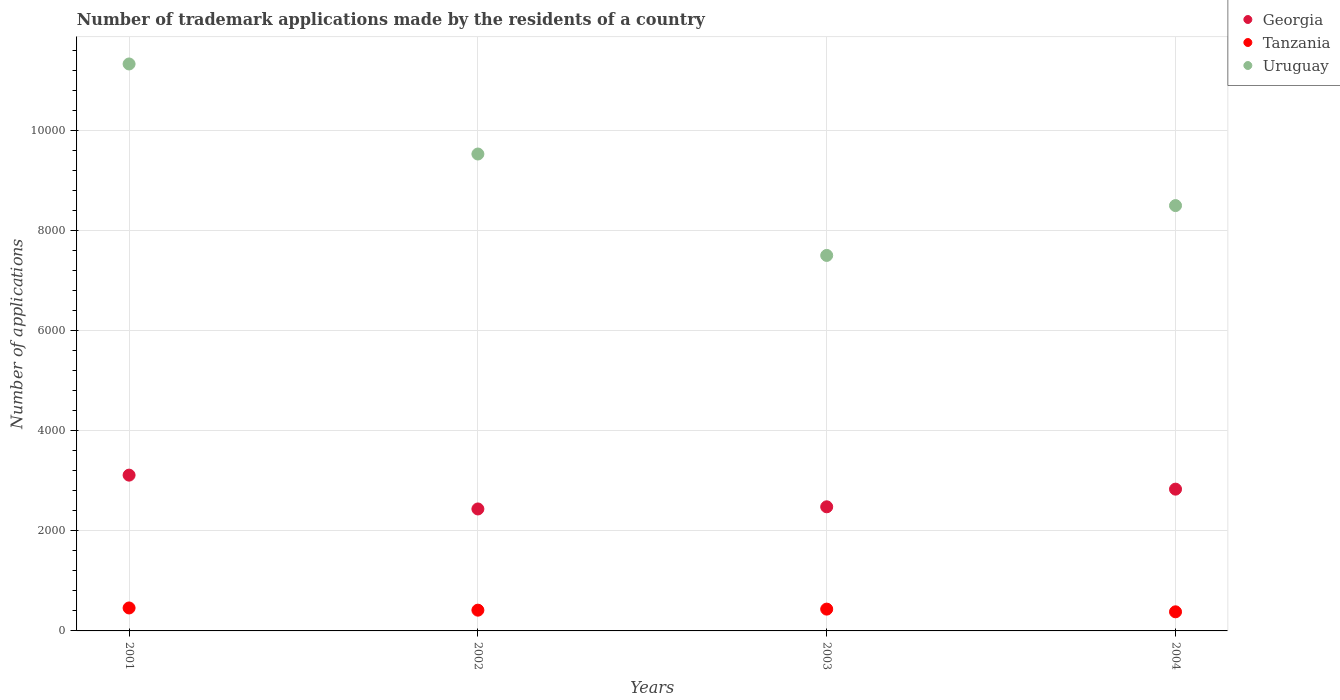How many different coloured dotlines are there?
Your response must be concise. 3. Is the number of dotlines equal to the number of legend labels?
Provide a succinct answer. Yes. What is the number of trademark applications made by the residents in Uruguay in 2001?
Provide a short and direct response. 1.13e+04. Across all years, what is the maximum number of trademark applications made by the residents in Uruguay?
Provide a succinct answer. 1.13e+04. Across all years, what is the minimum number of trademark applications made by the residents in Uruguay?
Offer a terse response. 7506. In which year was the number of trademark applications made by the residents in Georgia minimum?
Ensure brevity in your answer.  2002. What is the total number of trademark applications made by the residents in Uruguay in the graph?
Give a very brief answer. 3.69e+04. What is the difference between the number of trademark applications made by the residents in Tanzania in 2001 and that in 2002?
Give a very brief answer. 44. What is the difference between the number of trademark applications made by the residents in Tanzania in 2002 and the number of trademark applications made by the residents in Georgia in 2003?
Offer a terse response. -2066. What is the average number of trademark applications made by the residents in Uruguay per year?
Offer a terse response. 9218.5. In the year 2003, what is the difference between the number of trademark applications made by the residents in Tanzania and number of trademark applications made by the residents in Georgia?
Make the answer very short. -2045. What is the ratio of the number of trademark applications made by the residents in Tanzania in 2001 to that in 2004?
Offer a terse response. 1.2. Is the number of trademark applications made by the residents in Uruguay in 2002 less than that in 2003?
Make the answer very short. No. What is the difference between the highest and the second highest number of trademark applications made by the residents in Georgia?
Ensure brevity in your answer.  280. What is the difference between the highest and the lowest number of trademark applications made by the residents in Georgia?
Offer a very short reply. 676. Is the sum of the number of trademark applications made by the residents in Georgia in 2001 and 2002 greater than the maximum number of trademark applications made by the residents in Tanzania across all years?
Give a very brief answer. Yes. Does the number of trademark applications made by the residents in Georgia monotonically increase over the years?
Your answer should be compact. No. Is the number of trademark applications made by the residents in Uruguay strictly greater than the number of trademark applications made by the residents in Tanzania over the years?
Offer a terse response. Yes. How many years are there in the graph?
Keep it short and to the point. 4. What is the difference between two consecutive major ticks on the Y-axis?
Make the answer very short. 2000. Are the values on the major ticks of Y-axis written in scientific E-notation?
Offer a very short reply. No. Does the graph contain grids?
Offer a terse response. Yes. How many legend labels are there?
Your answer should be compact. 3. How are the legend labels stacked?
Provide a short and direct response. Vertical. What is the title of the graph?
Give a very brief answer. Number of trademark applications made by the residents of a country. What is the label or title of the X-axis?
Your answer should be very brief. Years. What is the label or title of the Y-axis?
Give a very brief answer. Number of applications. What is the Number of applications in Georgia in 2001?
Provide a short and direct response. 3114. What is the Number of applications of Tanzania in 2001?
Offer a terse response. 459. What is the Number of applications in Uruguay in 2001?
Give a very brief answer. 1.13e+04. What is the Number of applications of Georgia in 2002?
Keep it short and to the point. 2438. What is the Number of applications of Tanzania in 2002?
Offer a terse response. 415. What is the Number of applications in Uruguay in 2002?
Ensure brevity in your answer.  9533. What is the Number of applications in Georgia in 2003?
Keep it short and to the point. 2481. What is the Number of applications of Tanzania in 2003?
Offer a very short reply. 436. What is the Number of applications of Uruguay in 2003?
Your response must be concise. 7506. What is the Number of applications in Georgia in 2004?
Give a very brief answer. 2834. What is the Number of applications in Tanzania in 2004?
Give a very brief answer. 382. What is the Number of applications of Uruguay in 2004?
Provide a succinct answer. 8502. Across all years, what is the maximum Number of applications in Georgia?
Provide a succinct answer. 3114. Across all years, what is the maximum Number of applications of Tanzania?
Keep it short and to the point. 459. Across all years, what is the maximum Number of applications in Uruguay?
Keep it short and to the point. 1.13e+04. Across all years, what is the minimum Number of applications of Georgia?
Keep it short and to the point. 2438. Across all years, what is the minimum Number of applications in Tanzania?
Give a very brief answer. 382. Across all years, what is the minimum Number of applications of Uruguay?
Your answer should be very brief. 7506. What is the total Number of applications of Georgia in the graph?
Your answer should be compact. 1.09e+04. What is the total Number of applications of Tanzania in the graph?
Give a very brief answer. 1692. What is the total Number of applications in Uruguay in the graph?
Make the answer very short. 3.69e+04. What is the difference between the Number of applications in Georgia in 2001 and that in 2002?
Offer a very short reply. 676. What is the difference between the Number of applications in Tanzania in 2001 and that in 2002?
Ensure brevity in your answer.  44. What is the difference between the Number of applications of Uruguay in 2001 and that in 2002?
Give a very brief answer. 1800. What is the difference between the Number of applications in Georgia in 2001 and that in 2003?
Provide a short and direct response. 633. What is the difference between the Number of applications of Tanzania in 2001 and that in 2003?
Give a very brief answer. 23. What is the difference between the Number of applications in Uruguay in 2001 and that in 2003?
Keep it short and to the point. 3827. What is the difference between the Number of applications in Georgia in 2001 and that in 2004?
Give a very brief answer. 280. What is the difference between the Number of applications of Uruguay in 2001 and that in 2004?
Keep it short and to the point. 2831. What is the difference between the Number of applications of Georgia in 2002 and that in 2003?
Offer a terse response. -43. What is the difference between the Number of applications of Uruguay in 2002 and that in 2003?
Provide a short and direct response. 2027. What is the difference between the Number of applications of Georgia in 2002 and that in 2004?
Offer a terse response. -396. What is the difference between the Number of applications in Tanzania in 2002 and that in 2004?
Your response must be concise. 33. What is the difference between the Number of applications in Uruguay in 2002 and that in 2004?
Offer a terse response. 1031. What is the difference between the Number of applications in Georgia in 2003 and that in 2004?
Give a very brief answer. -353. What is the difference between the Number of applications in Tanzania in 2003 and that in 2004?
Your response must be concise. 54. What is the difference between the Number of applications of Uruguay in 2003 and that in 2004?
Make the answer very short. -996. What is the difference between the Number of applications of Georgia in 2001 and the Number of applications of Tanzania in 2002?
Provide a succinct answer. 2699. What is the difference between the Number of applications in Georgia in 2001 and the Number of applications in Uruguay in 2002?
Your answer should be very brief. -6419. What is the difference between the Number of applications in Tanzania in 2001 and the Number of applications in Uruguay in 2002?
Your response must be concise. -9074. What is the difference between the Number of applications in Georgia in 2001 and the Number of applications in Tanzania in 2003?
Ensure brevity in your answer.  2678. What is the difference between the Number of applications of Georgia in 2001 and the Number of applications of Uruguay in 2003?
Ensure brevity in your answer.  -4392. What is the difference between the Number of applications in Tanzania in 2001 and the Number of applications in Uruguay in 2003?
Make the answer very short. -7047. What is the difference between the Number of applications of Georgia in 2001 and the Number of applications of Tanzania in 2004?
Provide a short and direct response. 2732. What is the difference between the Number of applications in Georgia in 2001 and the Number of applications in Uruguay in 2004?
Your response must be concise. -5388. What is the difference between the Number of applications in Tanzania in 2001 and the Number of applications in Uruguay in 2004?
Keep it short and to the point. -8043. What is the difference between the Number of applications of Georgia in 2002 and the Number of applications of Tanzania in 2003?
Ensure brevity in your answer.  2002. What is the difference between the Number of applications in Georgia in 2002 and the Number of applications in Uruguay in 2003?
Your answer should be compact. -5068. What is the difference between the Number of applications in Tanzania in 2002 and the Number of applications in Uruguay in 2003?
Provide a short and direct response. -7091. What is the difference between the Number of applications of Georgia in 2002 and the Number of applications of Tanzania in 2004?
Keep it short and to the point. 2056. What is the difference between the Number of applications of Georgia in 2002 and the Number of applications of Uruguay in 2004?
Provide a short and direct response. -6064. What is the difference between the Number of applications in Tanzania in 2002 and the Number of applications in Uruguay in 2004?
Provide a succinct answer. -8087. What is the difference between the Number of applications in Georgia in 2003 and the Number of applications in Tanzania in 2004?
Your response must be concise. 2099. What is the difference between the Number of applications in Georgia in 2003 and the Number of applications in Uruguay in 2004?
Your answer should be very brief. -6021. What is the difference between the Number of applications of Tanzania in 2003 and the Number of applications of Uruguay in 2004?
Make the answer very short. -8066. What is the average Number of applications in Georgia per year?
Your response must be concise. 2716.75. What is the average Number of applications of Tanzania per year?
Keep it short and to the point. 423. What is the average Number of applications in Uruguay per year?
Provide a succinct answer. 9218.5. In the year 2001, what is the difference between the Number of applications of Georgia and Number of applications of Tanzania?
Make the answer very short. 2655. In the year 2001, what is the difference between the Number of applications of Georgia and Number of applications of Uruguay?
Offer a very short reply. -8219. In the year 2001, what is the difference between the Number of applications in Tanzania and Number of applications in Uruguay?
Your response must be concise. -1.09e+04. In the year 2002, what is the difference between the Number of applications of Georgia and Number of applications of Tanzania?
Your response must be concise. 2023. In the year 2002, what is the difference between the Number of applications in Georgia and Number of applications in Uruguay?
Make the answer very short. -7095. In the year 2002, what is the difference between the Number of applications of Tanzania and Number of applications of Uruguay?
Make the answer very short. -9118. In the year 2003, what is the difference between the Number of applications in Georgia and Number of applications in Tanzania?
Ensure brevity in your answer.  2045. In the year 2003, what is the difference between the Number of applications of Georgia and Number of applications of Uruguay?
Your response must be concise. -5025. In the year 2003, what is the difference between the Number of applications of Tanzania and Number of applications of Uruguay?
Ensure brevity in your answer.  -7070. In the year 2004, what is the difference between the Number of applications of Georgia and Number of applications of Tanzania?
Provide a short and direct response. 2452. In the year 2004, what is the difference between the Number of applications in Georgia and Number of applications in Uruguay?
Give a very brief answer. -5668. In the year 2004, what is the difference between the Number of applications of Tanzania and Number of applications of Uruguay?
Offer a terse response. -8120. What is the ratio of the Number of applications of Georgia in 2001 to that in 2002?
Offer a terse response. 1.28. What is the ratio of the Number of applications of Tanzania in 2001 to that in 2002?
Give a very brief answer. 1.11. What is the ratio of the Number of applications of Uruguay in 2001 to that in 2002?
Make the answer very short. 1.19. What is the ratio of the Number of applications in Georgia in 2001 to that in 2003?
Provide a short and direct response. 1.26. What is the ratio of the Number of applications of Tanzania in 2001 to that in 2003?
Keep it short and to the point. 1.05. What is the ratio of the Number of applications in Uruguay in 2001 to that in 2003?
Provide a short and direct response. 1.51. What is the ratio of the Number of applications in Georgia in 2001 to that in 2004?
Keep it short and to the point. 1.1. What is the ratio of the Number of applications of Tanzania in 2001 to that in 2004?
Keep it short and to the point. 1.2. What is the ratio of the Number of applications of Uruguay in 2001 to that in 2004?
Give a very brief answer. 1.33. What is the ratio of the Number of applications of Georgia in 2002 to that in 2003?
Your answer should be compact. 0.98. What is the ratio of the Number of applications in Tanzania in 2002 to that in 2003?
Offer a very short reply. 0.95. What is the ratio of the Number of applications of Uruguay in 2002 to that in 2003?
Your answer should be very brief. 1.27. What is the ratio of the Number of applications of Georgia in 2002 to that in 2004?
Your response must be concise. 0.86. What is the ratio of the Number of applications in Tanzania in 2002 to that in 2004?
Ensure brevity in your answer.  1.09. What is the ratio of the Number of applications in Uruguay in 2002 to that in 2004?
Keep it short and to the point. 1.12. What is the ratio of the Number of applications in Georgia in 2003 to that in 2004?
Keep it short and to the point. 0.88. What is the ratio of the Number of applications in Tanzania in 2003 to that in 2004?
Ensure brevity in your answer.  1.14. What is the ratio of the Number of applications in Uruguay in 2003 to that in 2004?
Make the answer very short. 0.88. What is the difference between the highest and the second highest Number of applications of Georgia?
Your response must be concise. 280. What is the difference between the highest and the second highest Number of applications in Uruguay?
Your answer should be compact. 1800. What is the difference between the highest and the lowest Number of applications of Georgia?
Make the answer very short. 676. What is the difference between the highest and the lowest Number of applications in Tanzania?
Offer a very short reply. 77. What is the difference between the highest and the lowest Number of applications of Uruguay?
Provide a succinct answer. 3827. 